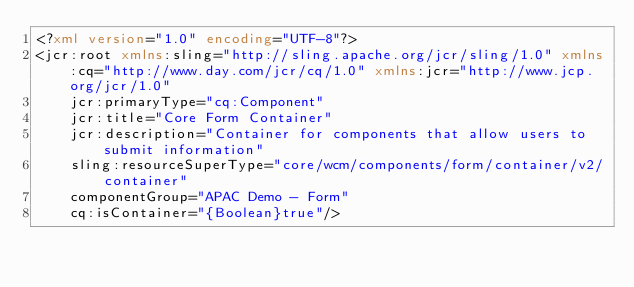<code> <loc_0><loc_0><loc_500><loc_500><_XML_><?xml version="1.0" encoding="UTF-8"?>
<jcr:root xmlns:sling="http://sling.apache.org/jcr/sling/1.0" xmlns:cq="http://www.day.com/jcr/cq/1.0" xmlns:jcr="http://www.jcp.org/jcr/1.0"
    jcr:primaryType="cq:Component"
    jcr:title="Core Form Container"
    jcr:description="Container for components that allow users to submit information"
    sling:resourceSuperType="core/wcm/components/form/container/v2/container"
    componentGroup="APAC Demo - Form"
    cq:isContainer="{Boolean}true"/>
</code> 